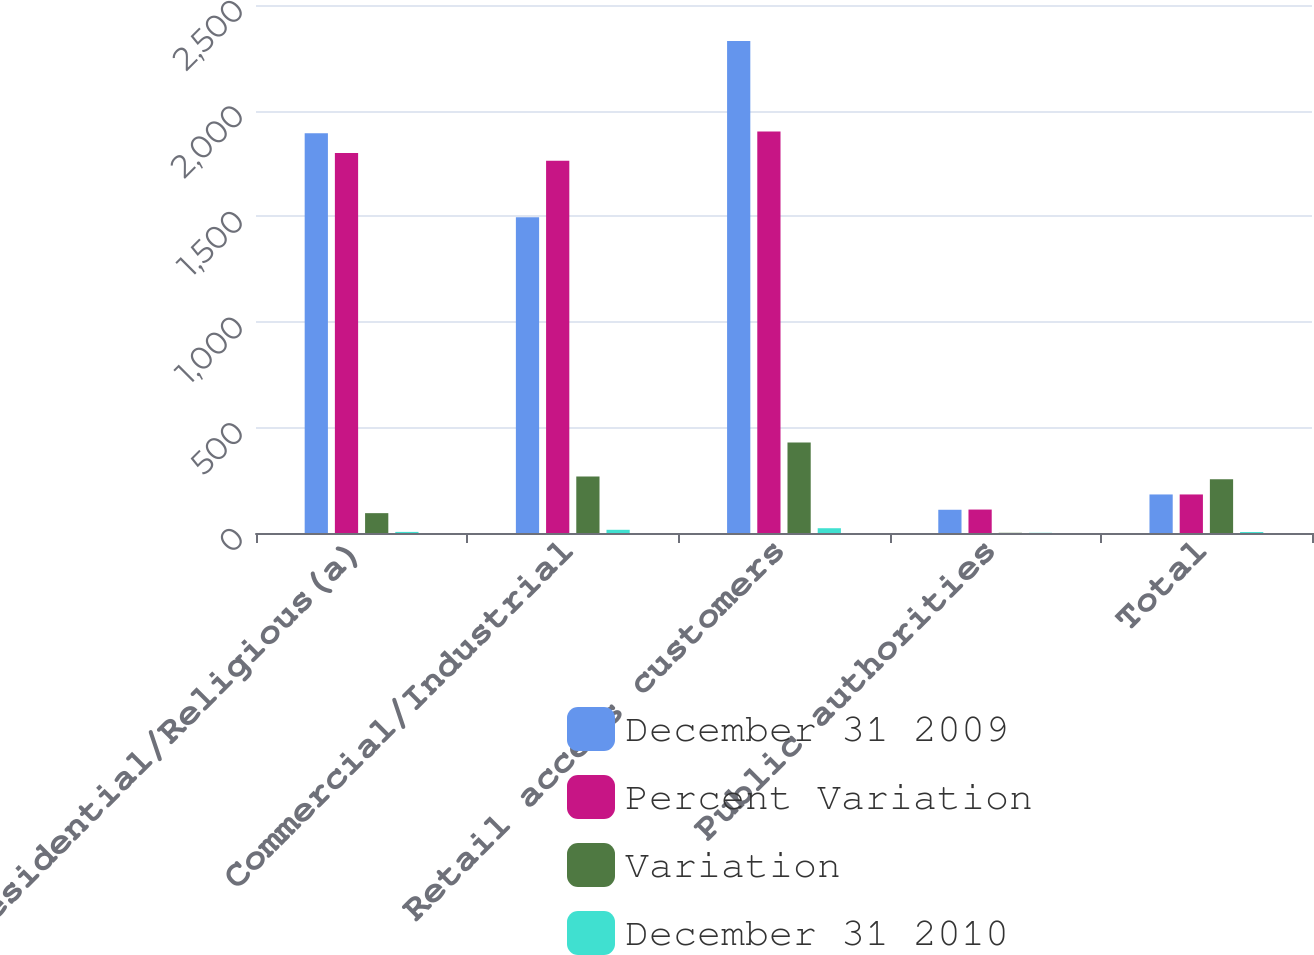Convert chart. <chart><loc_0><loc_0><loc_500><loc_500><stacked_bar_chart><ecel><fcel>Residential/Religious(a)<fcel>Commercial/Industrial<fcel>Retail access customers<fcel>Public authorities<fcel>Total<nl><fcel>December 31 2009<fcel>1893<fcel>1495<fcel>2330<fcel>110<fcel>182.5<nl><fcel>Percent Variation<fcel>1799<fcel>1763<fcel>1901<fcel>111<fcel>182.5<nl><fcel>Variation<fcel>94<fcel>268<fcel>429<fcel>1<fcel>254<nl><fcel>December 31 2010<fcel>5.2<fcel>15.2<fcel>22.6<fcel>0.9<fcel>4.6<nl></chart> 